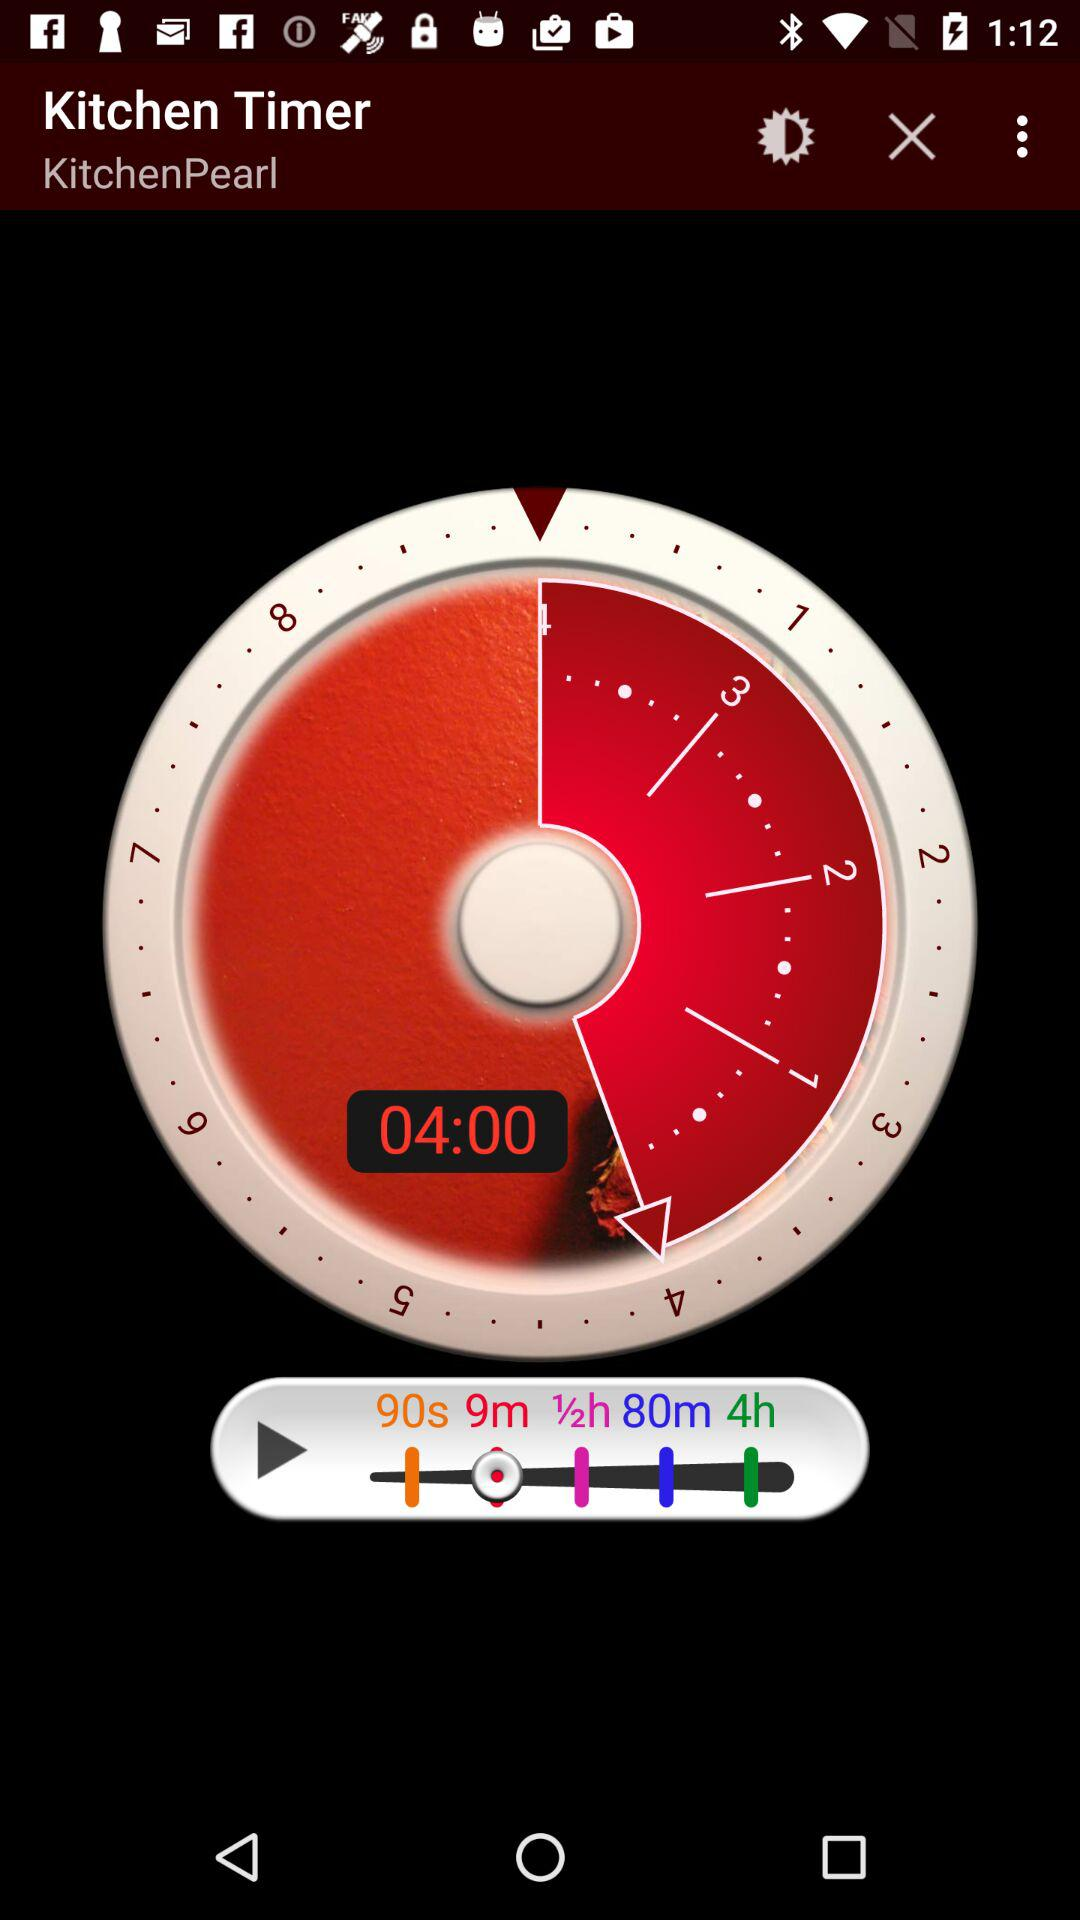Which version of the application is this?
When the provided information is insufficient, respond with <no answer>. <no answer> 